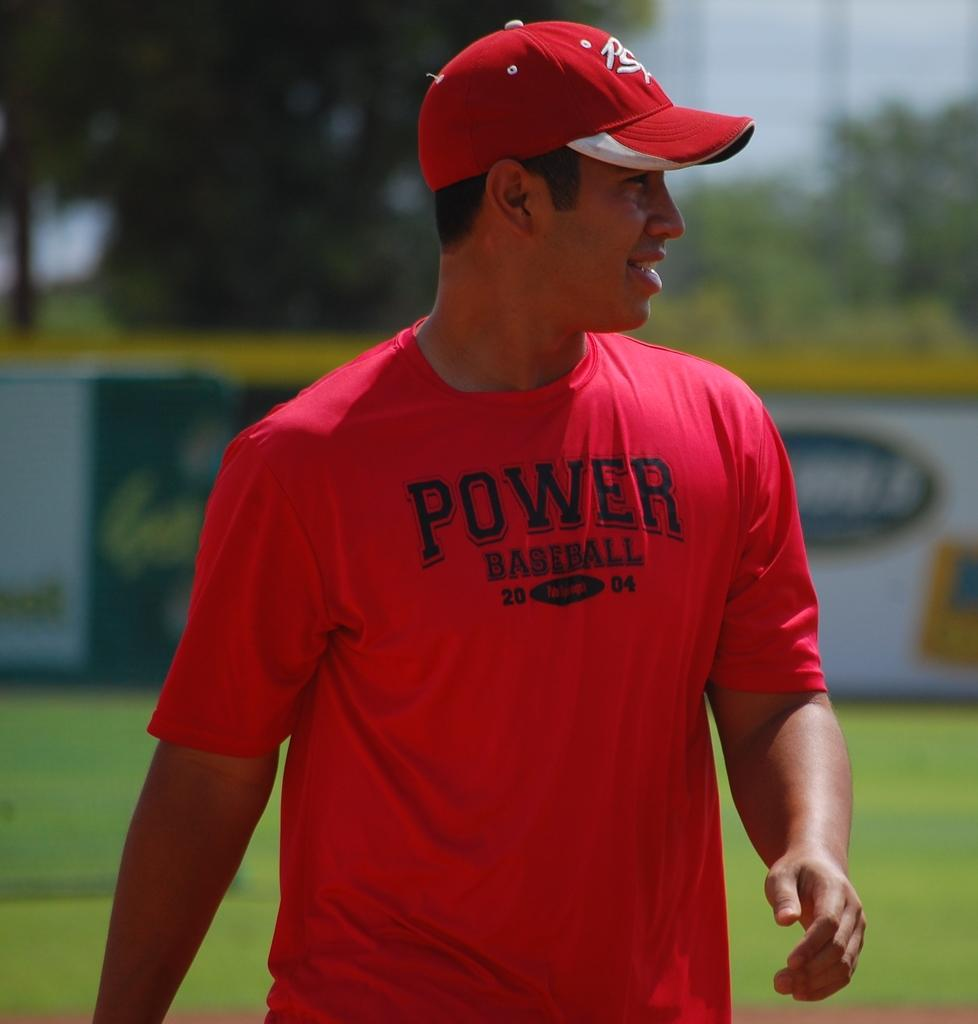Provide a one-sentence caption for the provided image. A man in a red T-shirt and ball cap is a proponent of Power Baseball. 